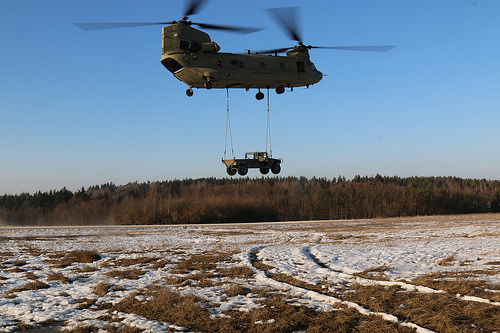<image>
Is the truck on the ground? No. The truck is not positioned on the ground. They may be near each other, but the truck is not supported by or resting on top of the ground. 